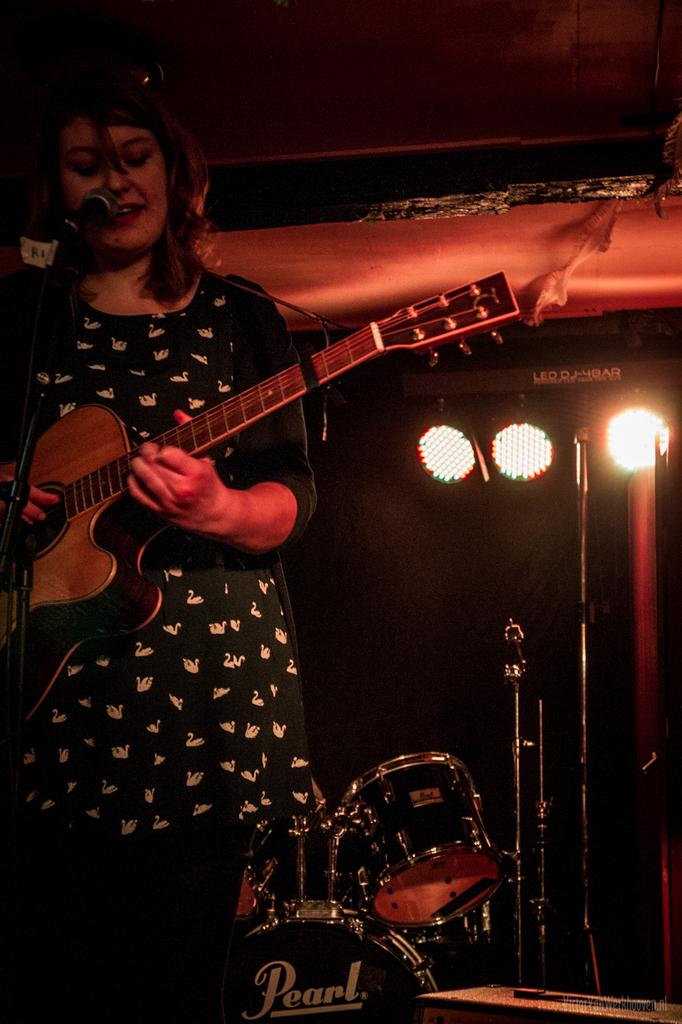What is the main subject of the image? There is a person in the image. What is the person doing in the image? The person is standing in front of a mic and playing a guitar. What other musical instruments can be seen in the image? There is a drum set in the image. What can be seen in the background of the image? There is lighting visible in the image. What is the person's annual income in the image? There is no information about the person's income in the image. How many eyes does the person have in the image? The person has two eyes in the image, but this information is not relevant to the main focus of the image, which is the person playing a guitar. 